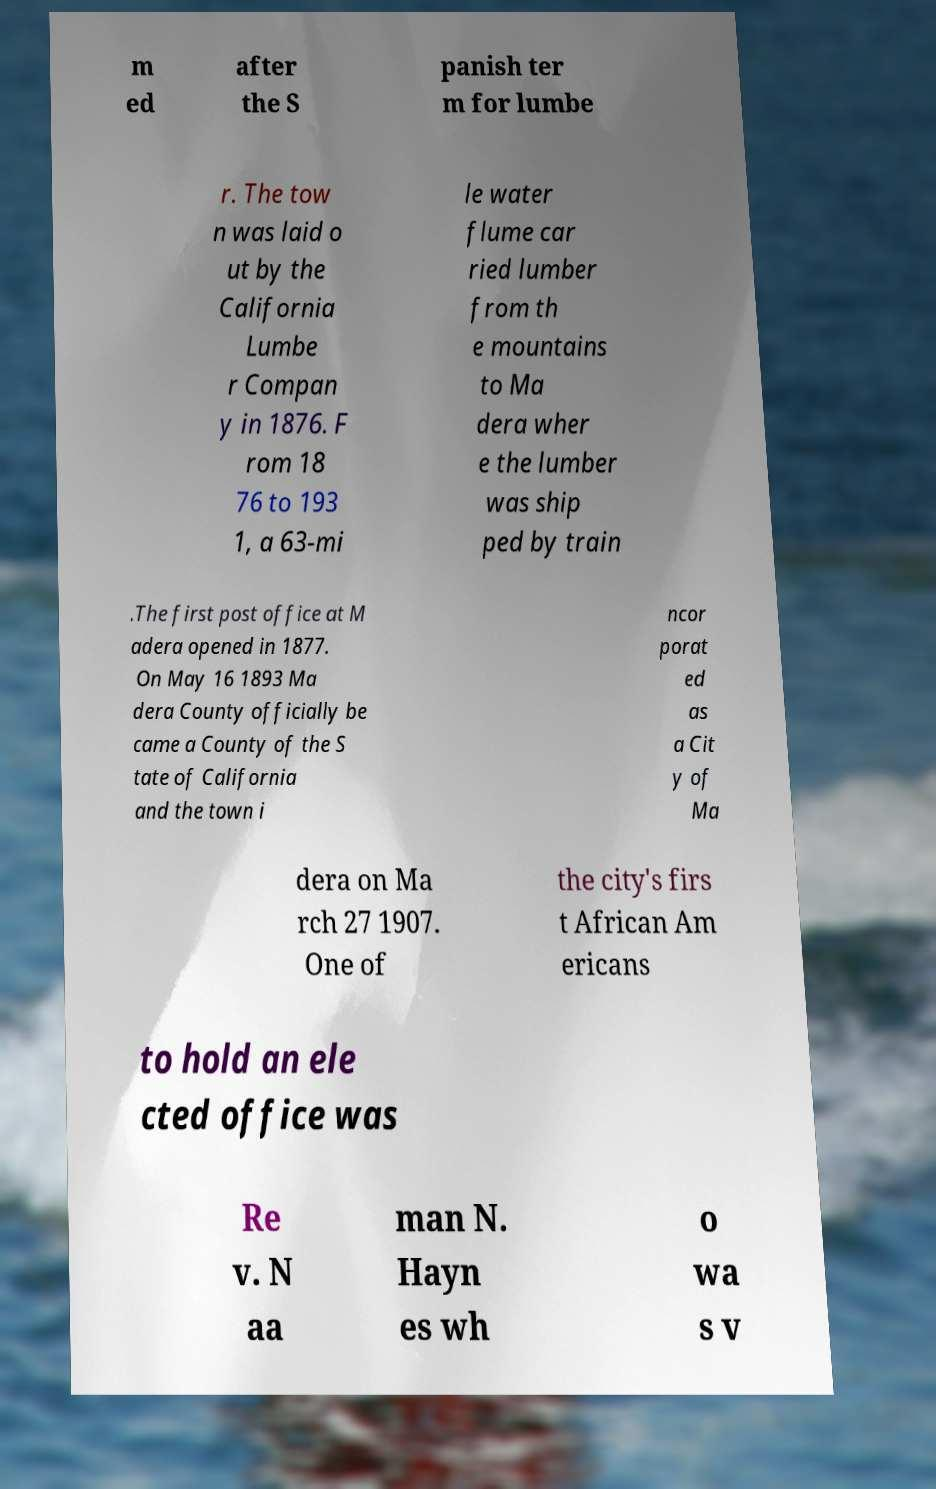Can you read and provide the text displayed in the image?This photo seems to have some interesting text. Can you extract and type it out for me? m ed after the S panish ter m for lumbe r. The tow n was laid o ut by the California Lumbe r Compan y in 1876. F rom 18 76 to 193 1, a 63-mi le water flume car ried lumber from th e mountains to Ma dera wher e the lumber was ship ped by train .The first post office at M adera opened in 1877. On May 16 1893 Ma dera County officially be came a County of the S tate of California and the town i ncor porat ed as a Cit y of Ma dera on Ma rch 27 1907. One of the city's firs t African Am ericans to hold an ele cted office was Re v. N aa man N. Hayn es wh o wa s v 